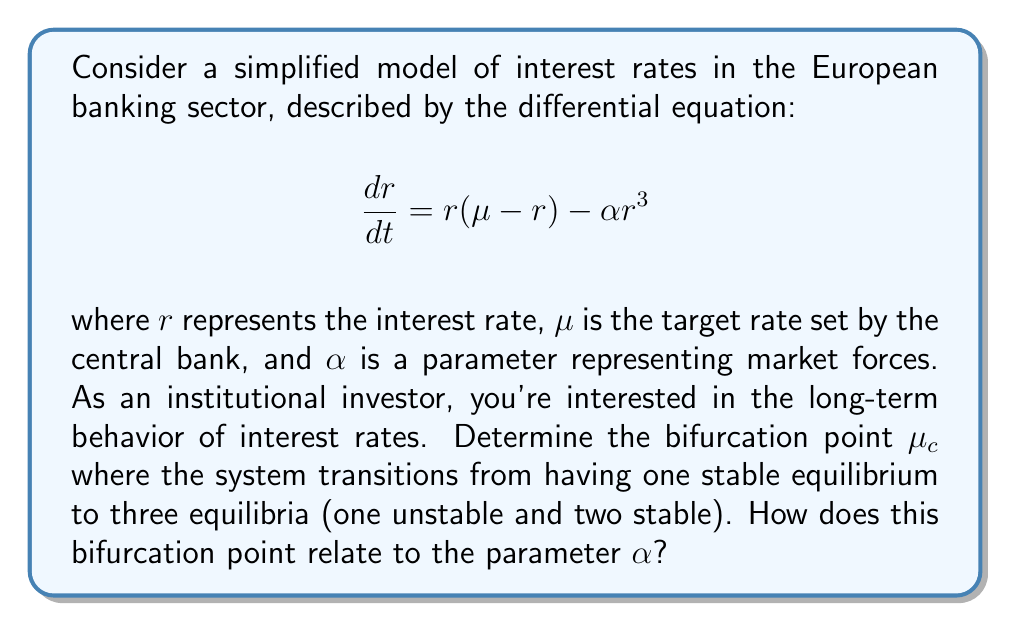Can you solve this math problem? To analyze the long-term behavior of interest rates using bifurcation theory, we'll follow these steps:

1) First, find the equilibrium points by setting $\frac{dr}{dt} = 0$:

   $$r(\mu - r) - \alpha r^3 = 0$$
   $$r(\mu - r - \alpha r^2) = 0$$

2) This equation has solutions $r = 0$ and $\mu - r - \alpha r^2 = 0$.

3) The non-zero solutions are given by:

   $$r = \frac{1 \pm \sqrt{1 + 4\alpha\mu}}{2\alpha}$$

4) For a pitchfork bifurcation, we need these two solutions to coincide. This occurs when the discriminant is zero:

   $$1 + 4\alpha\mu = 0$$

5) Solving for $\mu$, we get the bifurcation point:

   $$\mu_c = -\frac{1}{4\alpha}$$

6) At this point, the system transitions from having one stable equilibrium ($\mu < \mu_c$) to three equilibria ($\mu > \mu_c$), with two stable and one unstable.

7) The relationship between $\mu_c$ and $\alpha$ is inverse: as $\alpha$ increases, $\mu_c$ decreases, meaning the bifurcation occurs at lower target rates for stronger market forces.

This bifurcation analysis provides insights into potential interest rate regimes and their stability, crucial for long-term investment strategies in European banks.
Answer: $\mu_c = -\frac{1}{4\alpha}$ 